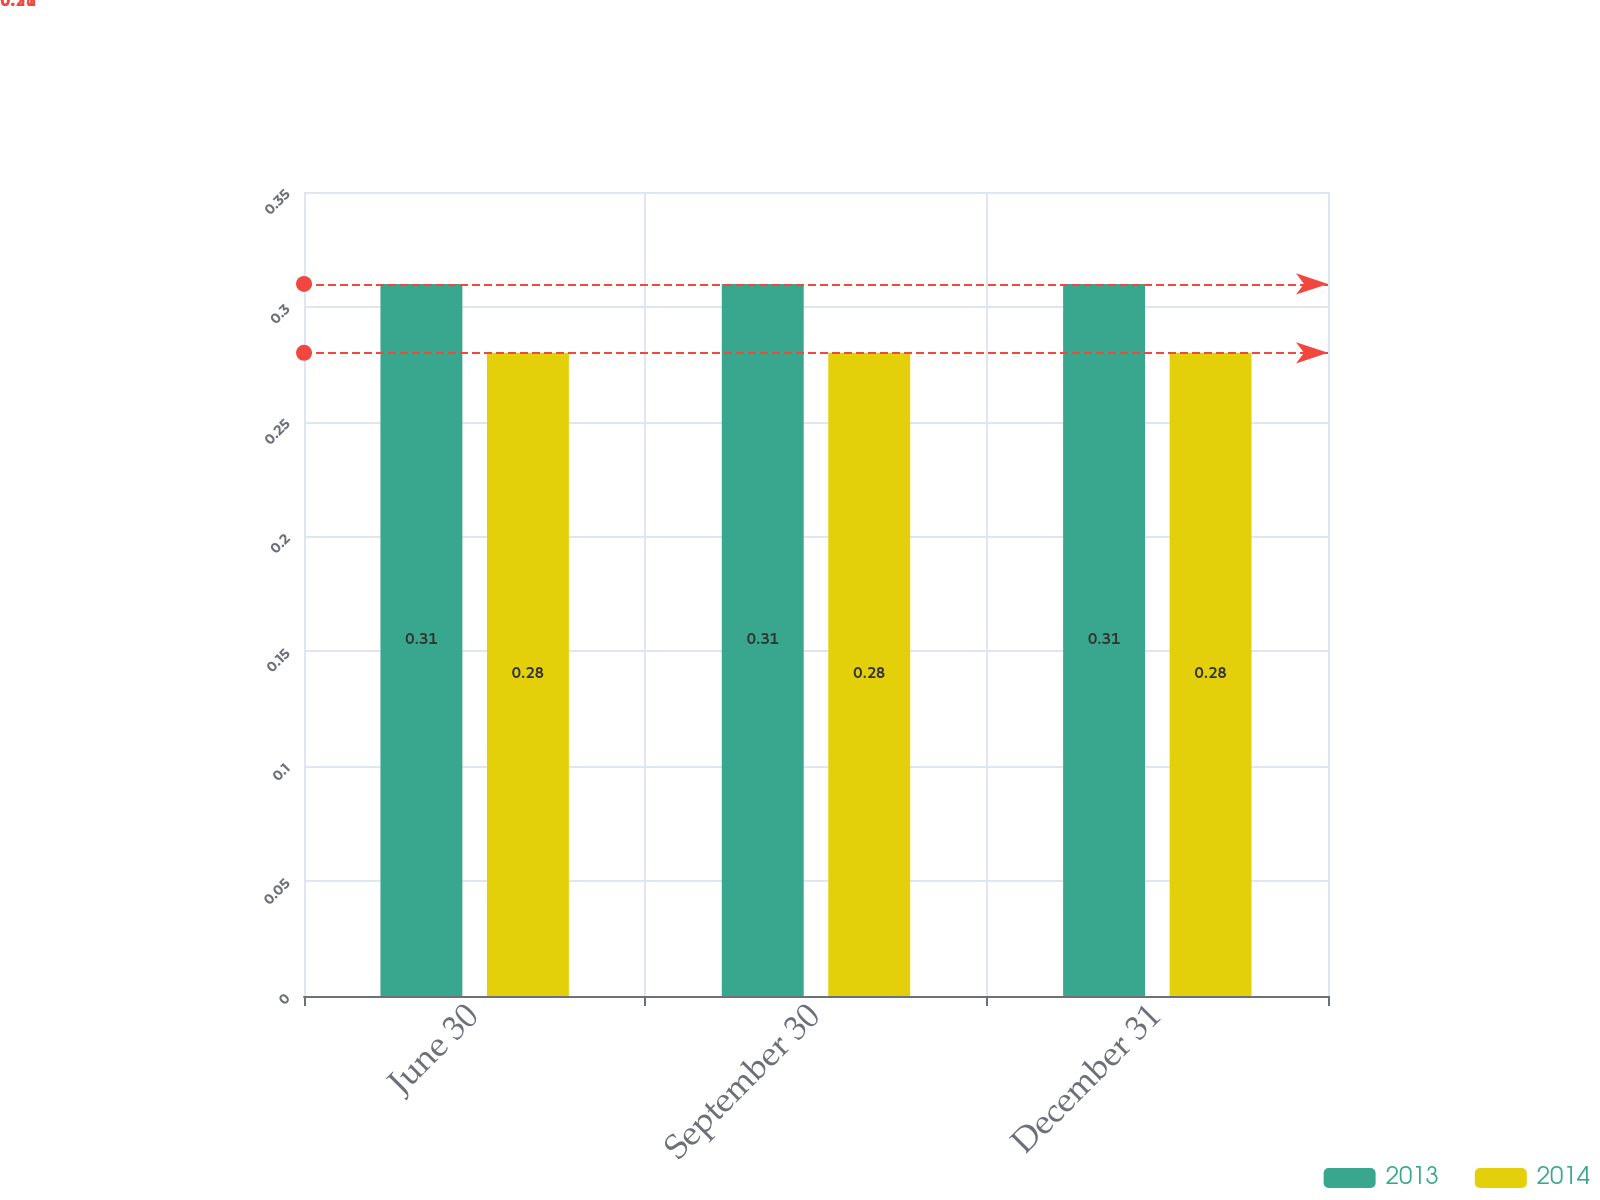Convert chart to OTSL. <chart><loc_0><loc_0><loc_500><loc_500><stacked_bar_chart><ecel><fcel>June 30<fcel>September 30<fcel>December 31<nl><fcel>2013<fcel>0.31<fcel>0.31<fcel>0.31<nl><fcel>2014<fcel>0.28<fcel>0.28<fcel>0.28<nl></chart> 